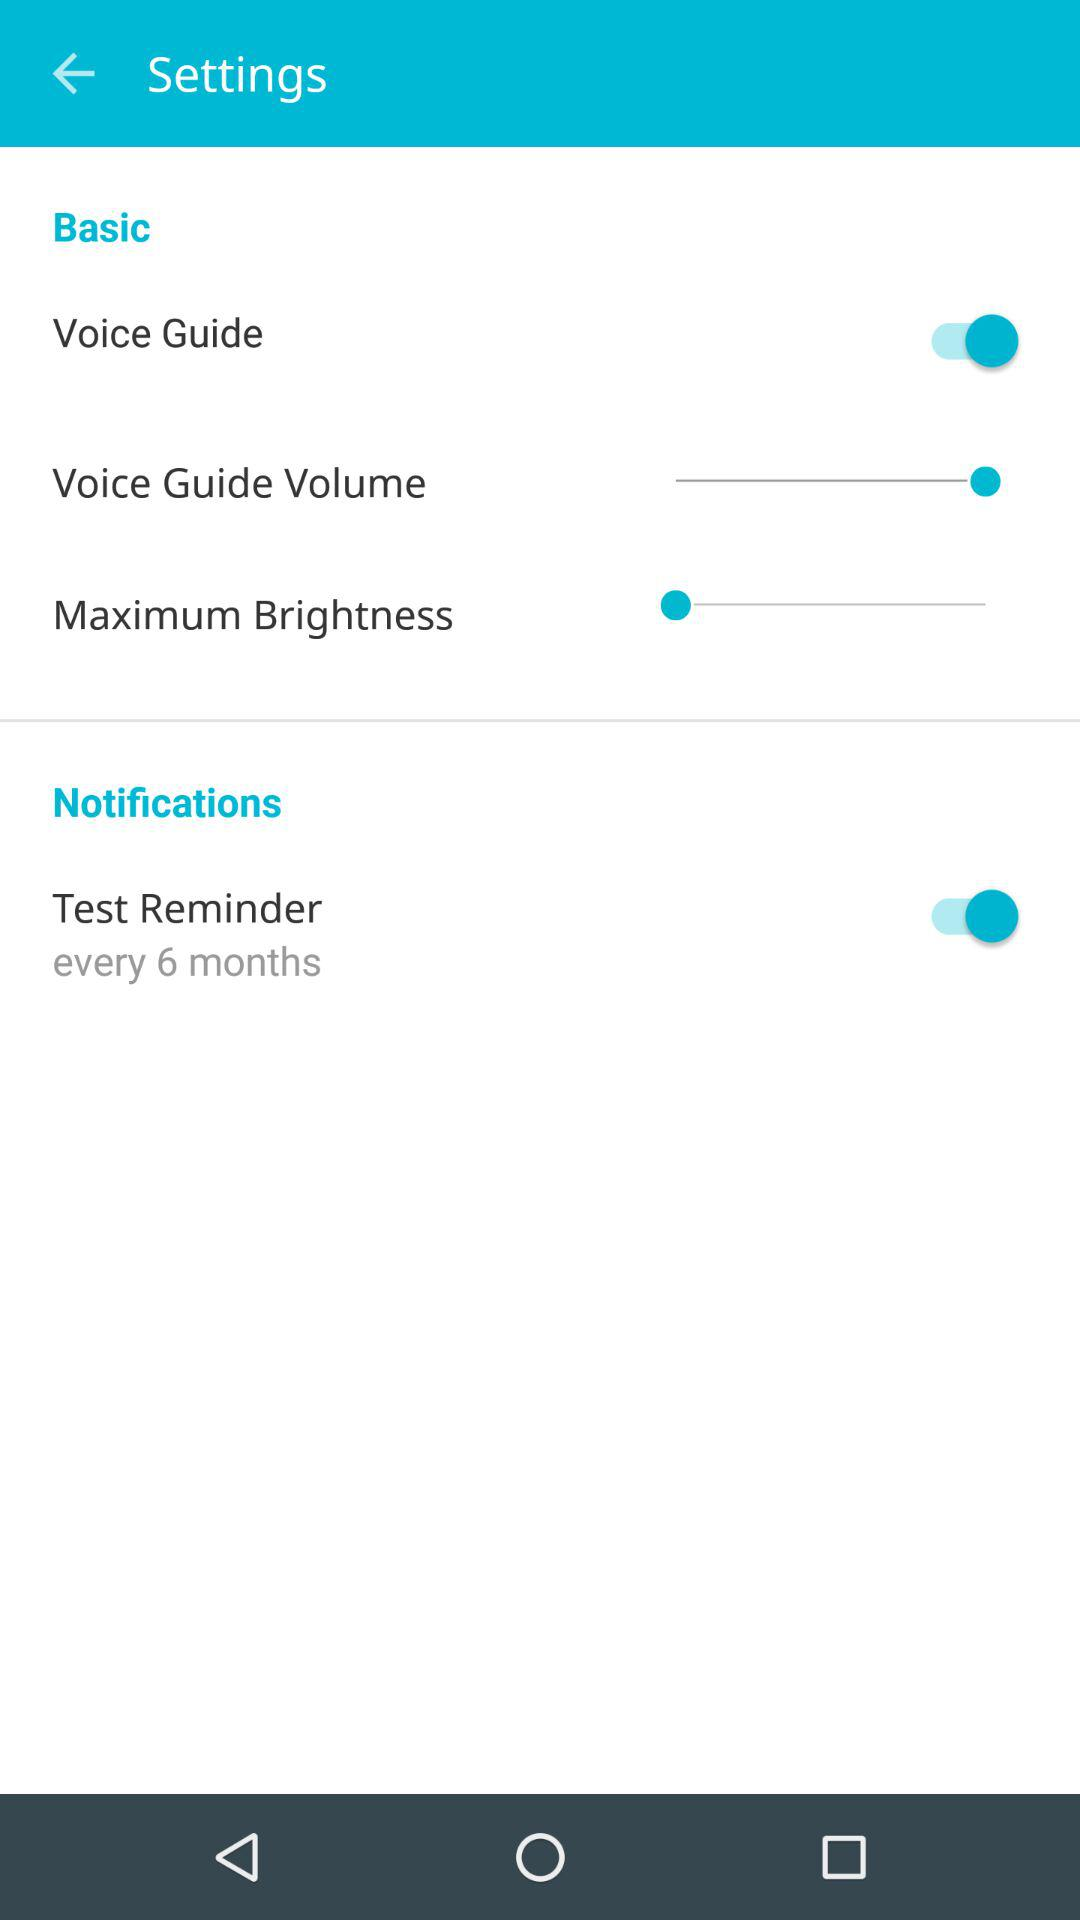Is "Notifications" checked or unchecked?
When the provided information is insufficient, respond with <no answer>. <no answer> 